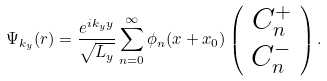Convert formula to latex. <formula><loc_0><loc_0><loc_500><loc_500>\Psi _ { k _ { y } } ( { r } ) = \frac { e ^ { i k _ { y } y } } { \sqrt { L _ { y } } } \sum _ { n = 0 } ^ { \infty } \phi _ { n } ( x + x _ { 0 } ) \left ( \begin{array} { c } C _ { n } ^ { + } \\ C _ { n } ^ { - } \end{array} \right ) .</formula> 